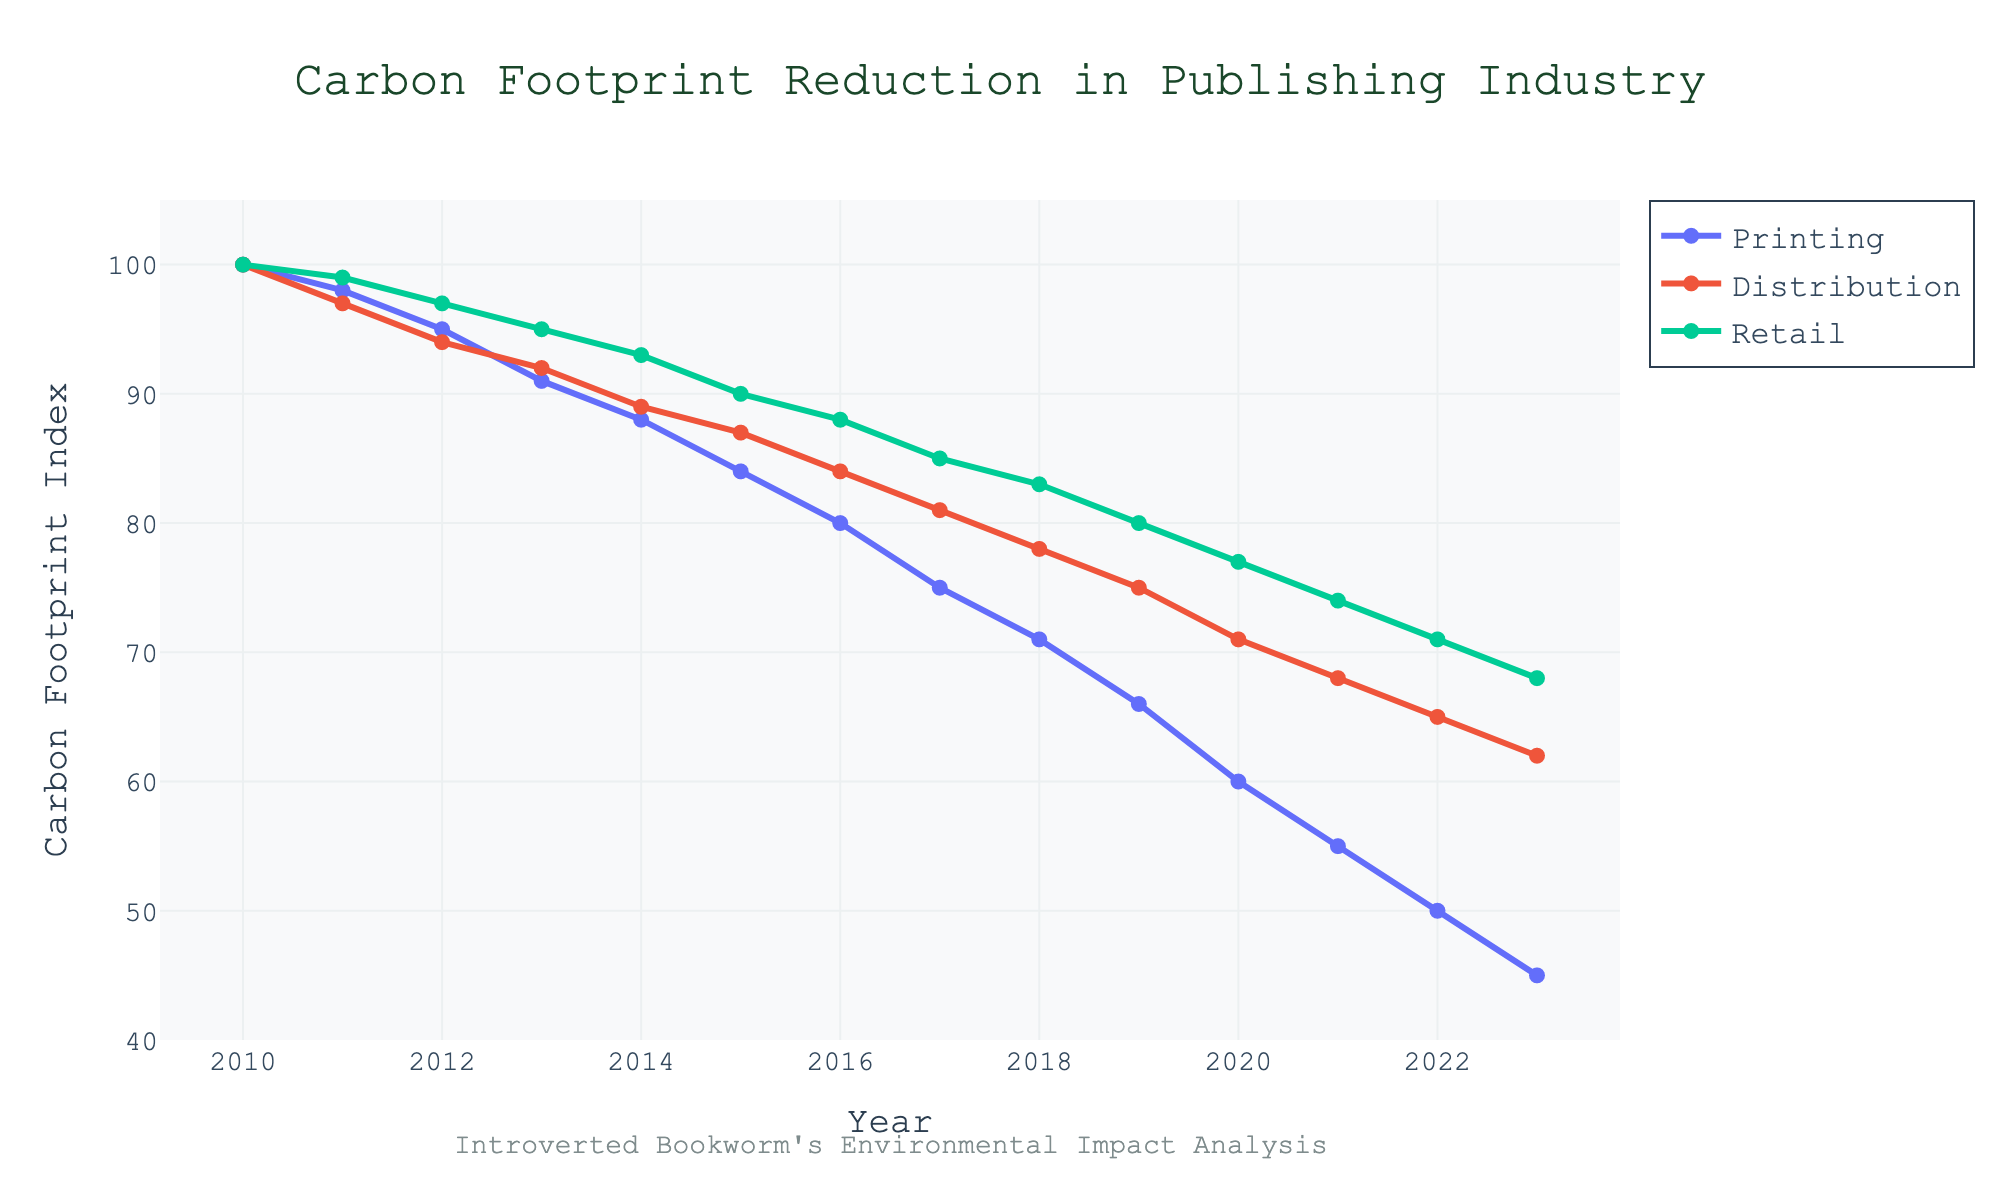What is the general trend in the carbon footprint for the Printing operational area from 2010 to 2023? The carbon footprint in the Printing operational area shows a consistent decreasing trend from 100 in 2010 to 45 in 2023.
Answer: Decreasing Which operational area had the smallest carbon footprint reduction between 2010 and 2023? By calculating the reduction for each area: Printing (100 - 45 = 55), Distribution (100 - 62 = 38), and Retail (100 - 68 = 32), we see that Retail had the smallest reduction.
Answer: Retail In which year did Retail's carbon footprint first fall below 80? By looking at the Retail line on the chart, Retail's carbon footprint first dropped below 80 in the year 2019.
Answer: 2019 Between 2011 and 2015, which operational area had the greatest absolute decrease in carbon footprint? Calculating the absolute decrease for each: Printing (98 - 84 = 14), Distribution (97 - 87 = 10), and Retail (99 - 90 = 9), Printing had the greatest decrease.
Answer: Printing How does the carbon footprint in the year 2020 compare across the three operational areas? In 2020, the Printing value is 60, Distribution is 71, and Retail is 77. Comparing these, Printing has the lowest, followed by Distribution and then Retail.
Answer: Printing < Distribution < Retail What is the average carbon footprint for the Distribution operational area from 2010 to 2023? Sum of Distribution values (100 + 97 + … + 62) = 1182. Dividing by the number of years (14) gives the average as 1182 / 14 = 84.43 (approx).
Answer: 84.43 In which year did the Printing operational area have the same carbon footprint as Retail? A visual comparison shows that the lines for Printing and Retail do not intersect precisely in any year.
Answer: Never By how many points did the carbon footprint of the Distribution area decrease from 2010 to 2015? The carbon footprint for Distribution in 2010 is 100 and in 2015 is 87. The decrease is 100 - 87 = 13 points.
Answer: 13 Between 2016 and 2020, which operational area saw the smallest reduction in the carbon footprint? Calculating the reduction: Printing (80 - 60 = 20), Distribution (84 - 71 = 13), and Retail (88 - 77 = 11). Retail saw the smallest reduction.
Answer: Retail What is the combined carbon footprint index of all operational areas in 2023? Adding carbon footprint values for 2023: 45 (Printing) + 62 (Distribution) + 68 (Retail) = 175.
Answer: 175 